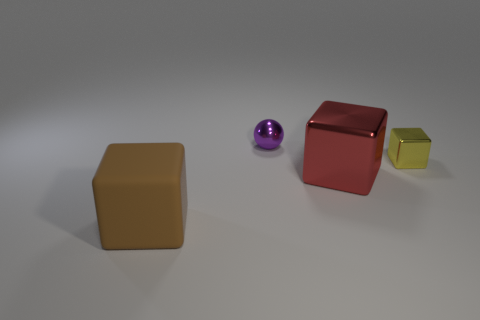Subtract all metallic blocks. How many blocks are left? 1 Subtract all yellow blocks. How many blocks are left? 2 Add 2 brown matte objects. How many objects exist? 6 Subtract 1 blocks. How many blocks are left? 2 Subtract all cubes. How many objects are left? 1 Subtract all green spheres. How many gray cubes are left? 0 Subtract all small cubes. Subtract all yellow objects. How many objects are left? 2 Add 2 big red things. How many big red things are left? 3 Add 2 big brown matte cubes. How many big brown matte cubes exist? 3 Subtract 0 brown spheres. How many objects are left? 4 